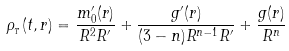<formula> <loc_0><loc_0><loc_500><loc_500>\rho _ { _ { T } } ( t , r ) = \frac { m _ { 0 } ^ { \prime } ( r ) } { R ^ { 2 } R ^ { \prime } } + \frac { g ^ { \prime } ( r ) } { ( 3 - n ) R ^ { n - 1 } R ^ { \prime } } + \frac { g ( r ) } { R ^ { n } }</formula> 